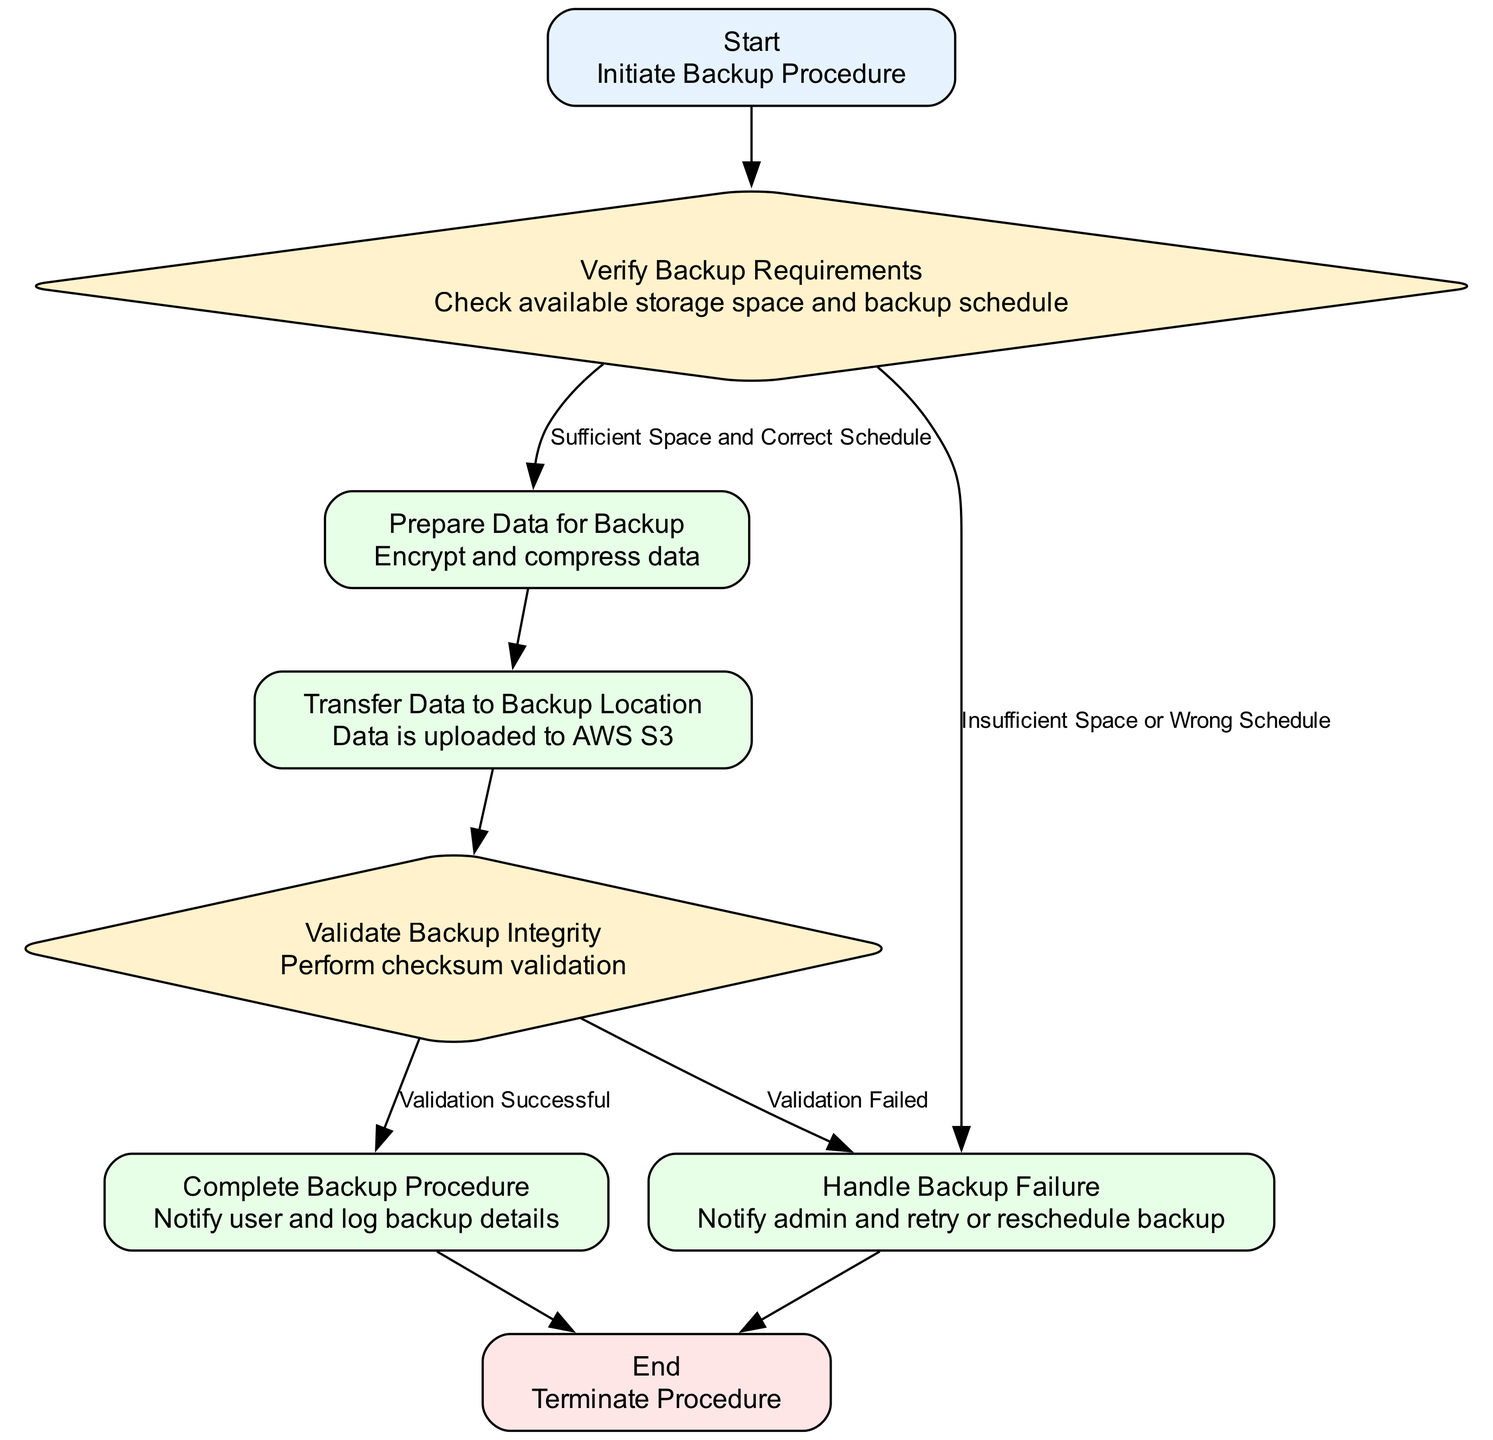What is the first action in the flowchart? The flowchart starts with the "Initiate Backup Procedure," which is the first action described.
Answer: Initiate Backup Procedure How many steps are there in the backup procedure? Counting the steps listed in the flowchart, there are a total of 6 steps before reaching the end.
Answer: 6 What happens if there is insufficient space or a wrong schedule? The flowchart indicates that if there is insufficient space or a wrong schedule, the next action is "Handle Backup Failure."
Answer: Handle Backup Failure What is the final action taken in the backup procedure? The last action in the flowchart before termination is to "Notify user and log backup details."
Answer: Notify user and log backup details How many decisions are present in the backup procedure? Analyzing the flowchart, there are two decision points: one after verifying backup requirements, and the other after validating backup integrity, making it two decisions in total.
Answer: 2 If the backup integrity validation fails, which step follows? The flowchart specifies that if validation fails, the next step is "Handle Backup Failure."
Answer: Handle Backup Failure What action is taken after preparing the data for backup? After the "Prepare Data for Backup" step, the next action is to "Transfer Data to Backup Location."
Answer: Transfer Data to Backup Location What decision occurs after validating backup integrity? The flowchart presents two outcomes after validating backup integrity: either "Validation Successful" or "Validation Failed."
Answer: Validation Successful, Validation Failed What node does the flowchart connect to after Step 1? The flowchart connects Step 1, which is "Verify Backup Requirements," directly to Step 2, "Prepare Data for Backup."
Answer: Step 2 